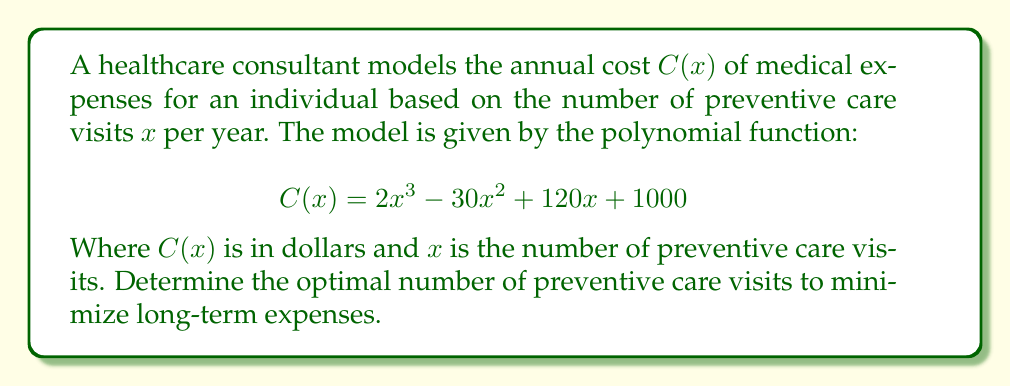Help me with this question. To find the optimal number of preventive care visits that minimizes long-term expenses, we need to find the minimum point of the given polynomial function. This can be done by following these steps:

1. Find the derivative of $C(x)$:
   $$C'(x) = 6x^2 - 60x + 120$$

2. Set the derivative equal to zero and solve for x:
   $$6x^2 - 60x + 120 = 0$$
   $$6(x^2 - 10x + 20) = 0$$
   $$6(x - 5)^2 - 30 = 0$$
   $$(x - 5)^2 = 5$$
   $$x - 5 = \pm \sqrt{5}$$
   $$x = 5 \pm \sqrt{5}$$

3. Find the critical points:
   $x_1 = 5 + \sqrt{5} \approx 7.24$
   $x_2 = 5 - \sqrt{5} \approx 2.76$

4. Check the second derivative to determine which critical point is the minimum:
   $$C''(x) = 12x - 60$$
   At $x_1$: $C''(7.24) > 0$, so this is a local minimum.
   At $x_2$: $C''(2.76) < 0$, so this is a local maximum.

5. Since we're looking for the minimum cost, the optimal number of preventive care visits is $x_1 = 5 + \sqrt{5} \approx 7.24$.

6. Round to the nearest whole number since we can't have fractional visits.
Answer: 7 visits per year 